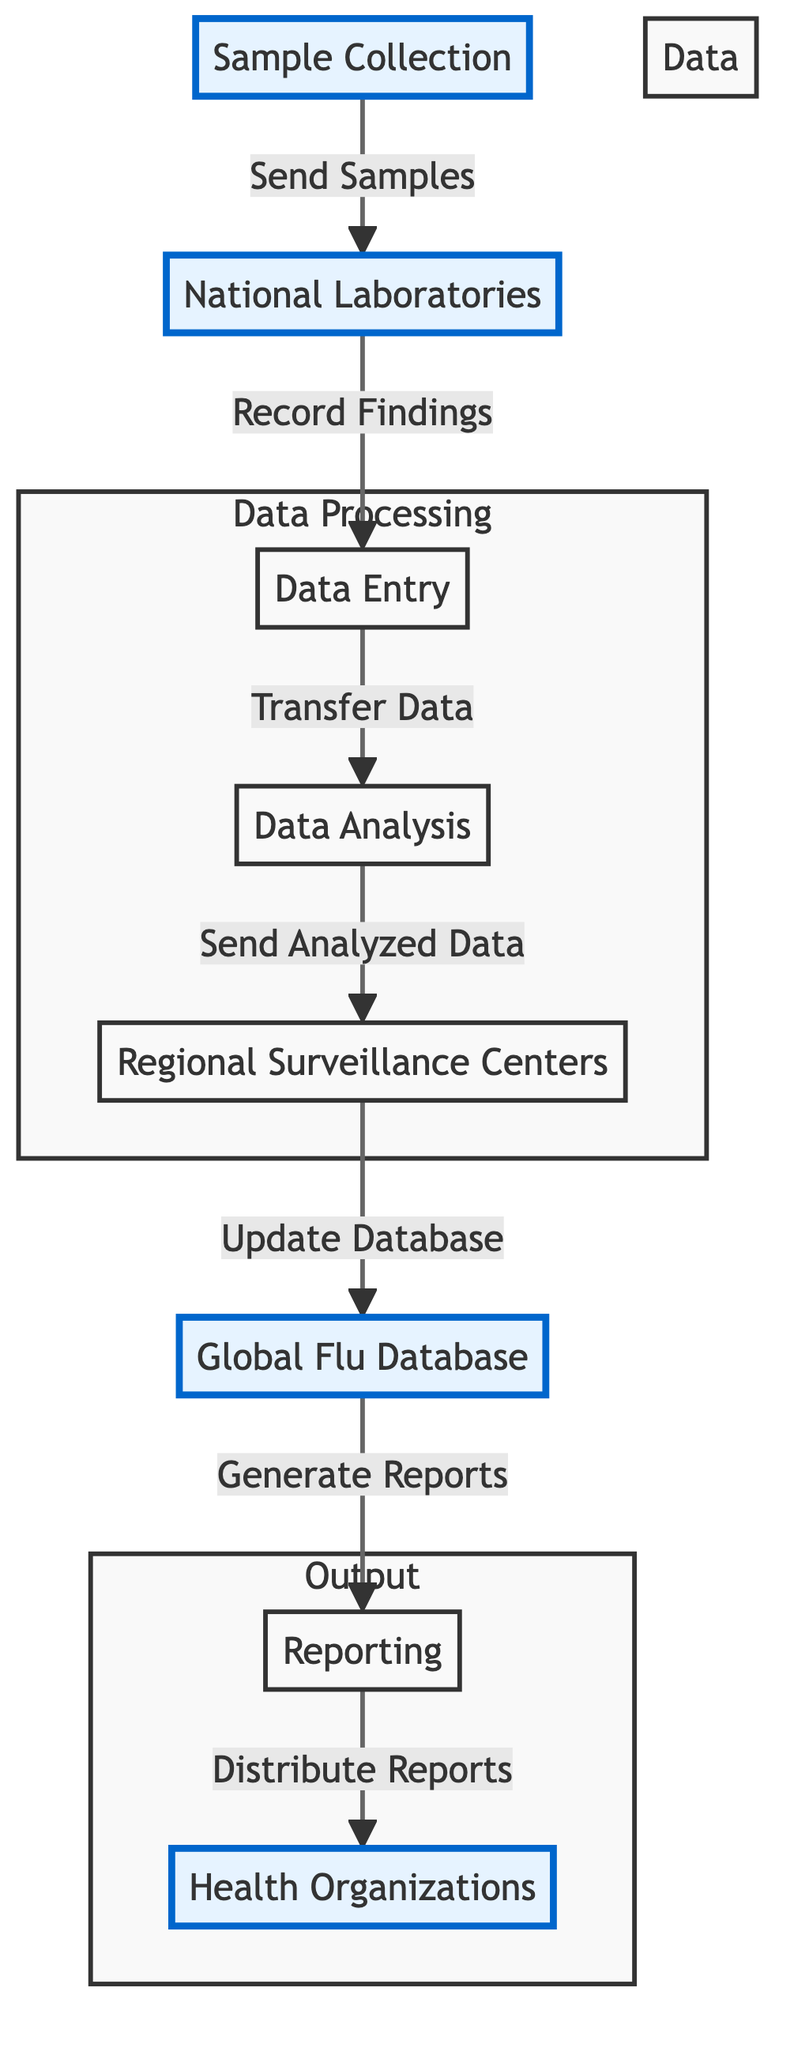What is the first step in the flowchart? The first step identified in the flowchart is 'Sample Collection,' which initiates the process of monitoring flu strains.
Answer: Sample Collection How many total nodes are there in the diagram? By counting each distinct labeled node in the flowchart, we determine there are eight nodes present.
Answer: Eight What is the relationship between 'National Laboratories' and 'Data Entry'? In the flowchart, 'National Laboratories' sends findings to 'Data Entry,' indicating that it is a directional flow from one node to the next.
Answer: Sends Findings Which node is responsible for updating the database? The node responsible for updating the database is 'Regional Surveillance Centers,' as indicated in the flowchart which shows the data flow from analysis to updating the database.
Answer: Regional Surveillance Centers What is the last node in the processing chain? The last node in the processing chain is 'Health Organizations,' which receives reports generated from the analyzed data shared across the network.
Answer: Health Organizations How does data flow from 'Data Analysis' to 'Global Flu Database'? The data flows from 'Data Analysis' to 'Regional Surveillance Centers,' which in turn updates the 'Global Flu Database,' indicating a two-step process of transfer.
Answer: Two-step Process Which nodes are emphasized in the diagram? The emphasized nodes are 'Sample Collection,' 'National Laboratories,' 'Global Flu Database,' and 'Health Organizations,' as visually indicated through styling in the diagram.
Answer: Sample Collection, National Laboratories, Global Flu Database, Health Organizations What does 'Reporting' generate? 'Reporting' in the flowchart generates 'Reports,' which is then distributed to other nodes in the network.
Answer: Reports 